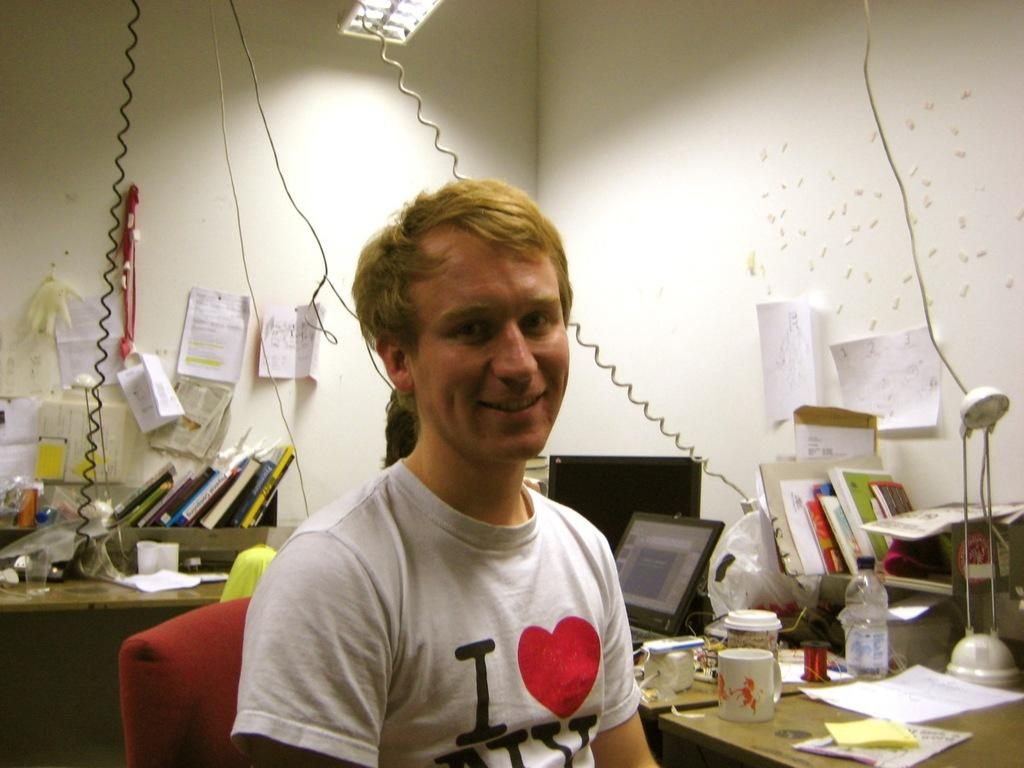<image>
Give a short and clear explanation of the subsequent image. man wearing i heart ny tshirt  shitting at a messy desk 